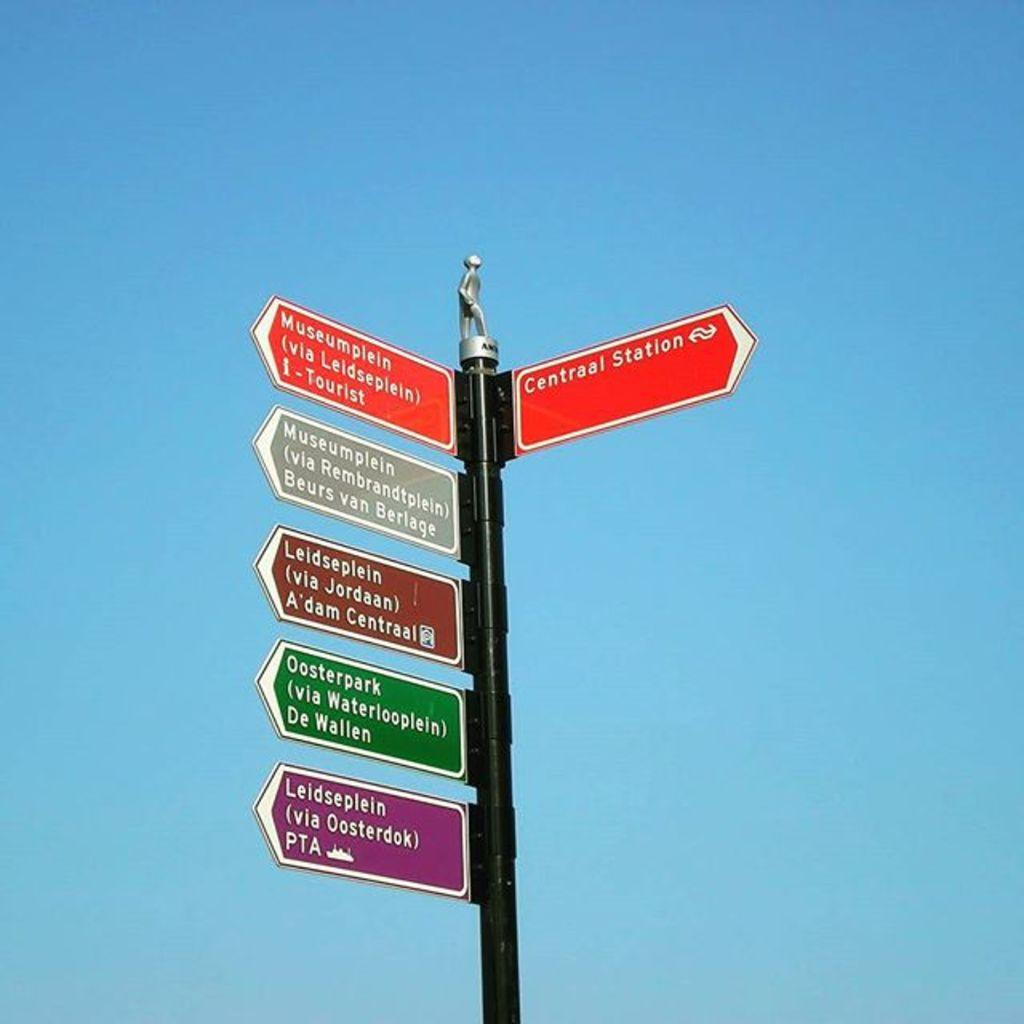<image>
Offer a succinct explanation of the picture presented. many colorful signs like Centraal Station line a pole 